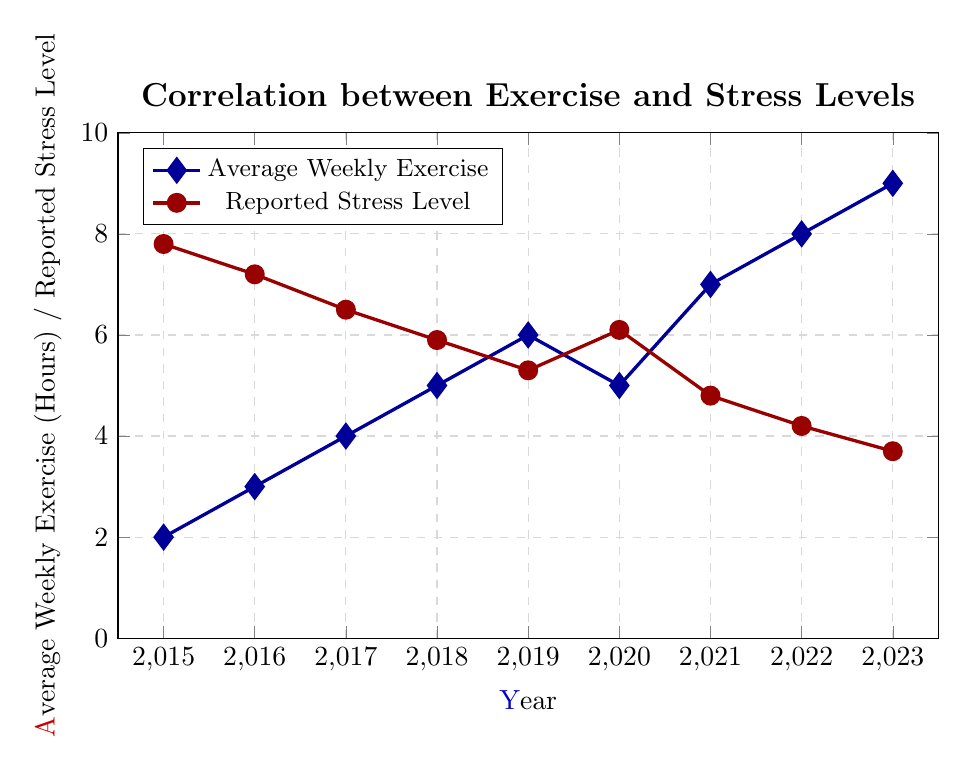How does the reported stress level in 2023 compare to that in 2015? The reported stress level in 2015 is 7.8, and the reported stress level in 2023 is 3.7. We compare these two values directly.
Answer: The stress level in 2023 is lower than in 2015 What is the total increase in average weekly exercise hours from 2015 to 2023? In 2015, the average weekly exercise is 2 hours, and in 2023, it is 9 hours. Subtract the 2015 value from the 2023 value: 9 - 2.
Answer: 7 hours Between which consecutive years did the average weekly exercise increase the most? To find this, calculate the difference in average weekly exercise hours between each consecutive year and identify the largest increase. The differences are 1, 1, 1, 1, -1, 2, 1, 1. The largest increase is between 2020 and 2021, which is 2 hours.
Answer: 2020 and 2021 During which year was the reported stress level the highest? Look at the values of reported stress levels for each year and find the maximum value. The highest reported stress level is 7.8 in 2015.
Answer: 2015 How much did the reported stress level decrease from 2019 to 2023? The reported stress level in 2019 is 5.3, and in 2023, it is 3.7. Subtract the value in 2023 from the value in 2019: 5.3 - 3.7.
Answer: 1.6 What is the trend in average weekly exercise from 2015 to 2023? Examine the plot of average weekly exercise over the years from 2015 to 2023. The values generally increase over the years.
Answer: Increasing Compare the average weekly exercise in 2020 and 2021. Which year had higher exercise levels and by how much? In 2020, the average weekly exercise is 5 hours, and in 2021, it is 7 hours. Subtract the 2020 value from the 2021 value: 7 - 5.
Answer: 2021 had higher exercise levels by 2 hours Is there a noticeable relationship between average weekly exercise and reported stress level? Observe the trend in both datasets. As the average weekly exercise increases, the reported stress level generally decreases.
Answer: Yes, more exercise correlates with lower stress Did any year show an increase in reported stress levels compared to the previous year? Check if any reported stress level is higher than the previous year's level. The reported stress level increased from 2019 to 2020 (5.3 to 6.1).
Answer: Yes, 2020 What is the difference in reported stress level between the year with the highest stress level and the year with the lowest stress level? The highest reported stress level is in 2015 (7.8), and the lowest is in 2023 (3.7). Subtract the lowest value from the highest value: 7.8 - 3.7.
Answer: 4.1 